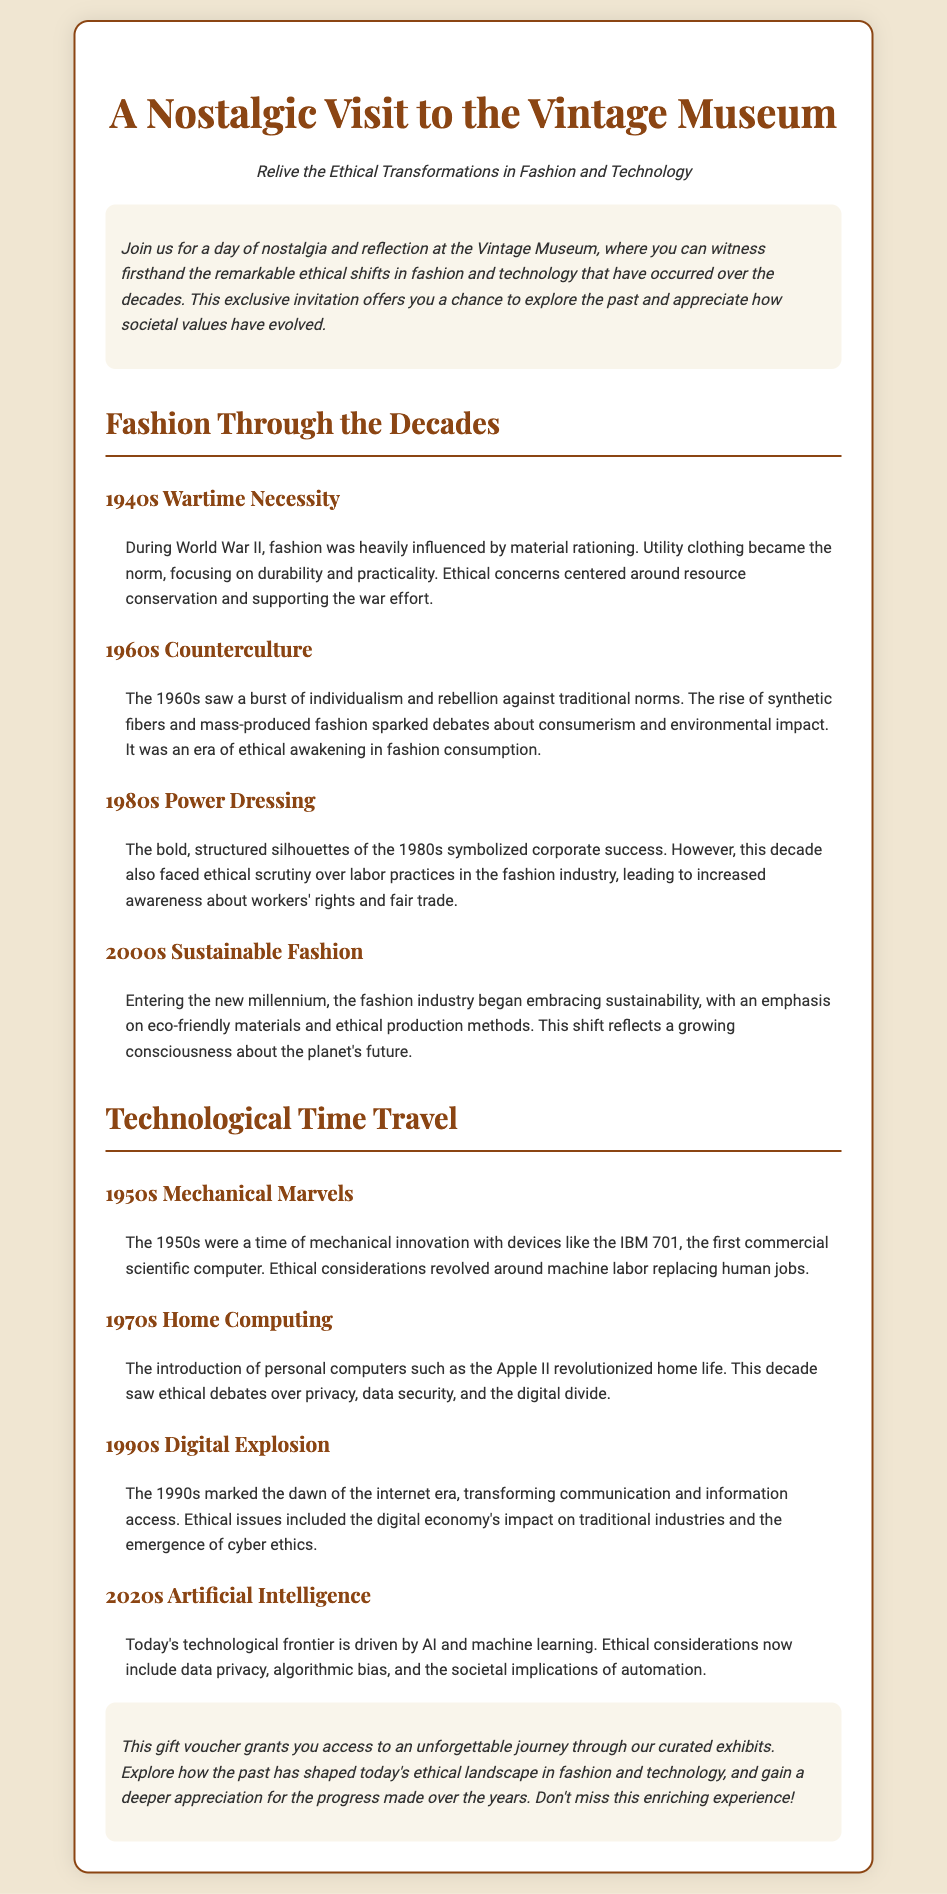What is the title of the voucher? The title clearly states what the voucher is for.
Answer: A Nostalgic Visit to the Vintage Museum What decade is associated with power dressing? The document lists the 1980s as the time when power dressing was prominent.
Answer: 1980s Which era saw the rise of synthetic fibers? The document indicates that synthetic fibers became popular during the 1960s.
Answer: 1960s What was a significant concern about the fashion industry in the 1980s? The document notes that labor practices were scrutinized during this time.
Answer: Labor practices What did the 2000s emphasize in fashion? The document states that the focus shifted toward sustainability and eco-friendly materials.
Answer: Sustainable fashion Which technological device was introduced in the 1950s? The document mentions the IBM 701 as the first commercial scientific computer.
Answer: IBM 701 What ethical issue arose with the advent of personal computers in the 1970s? The document highlights privacy and data security as key ethical debates.
Answer: Privacy What does this gift voucher allow the holder to do? The document specifies that the voucher grants access to curated exhibits.
Answer: Access curated exhibits What is the main focus of the Vintage Museum visit? The document emphasizes witnessing ethical transformations in fashion and technology.
Answer: Ethical transformations in fashion and technology 